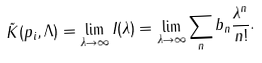<formula> <loc_0><loc_0><loc_500><loc_500>\tilde { K } ( p _ { i } , \Lambda ) = \lim _ { \lambda \rightarrow \infty } I ( \lambda ) = \lim _ { \lambda \rightarrow \infty } \sum _ { n } b _ { n } \frac { \lambda ^ { n } } { n ! } .</formula> 